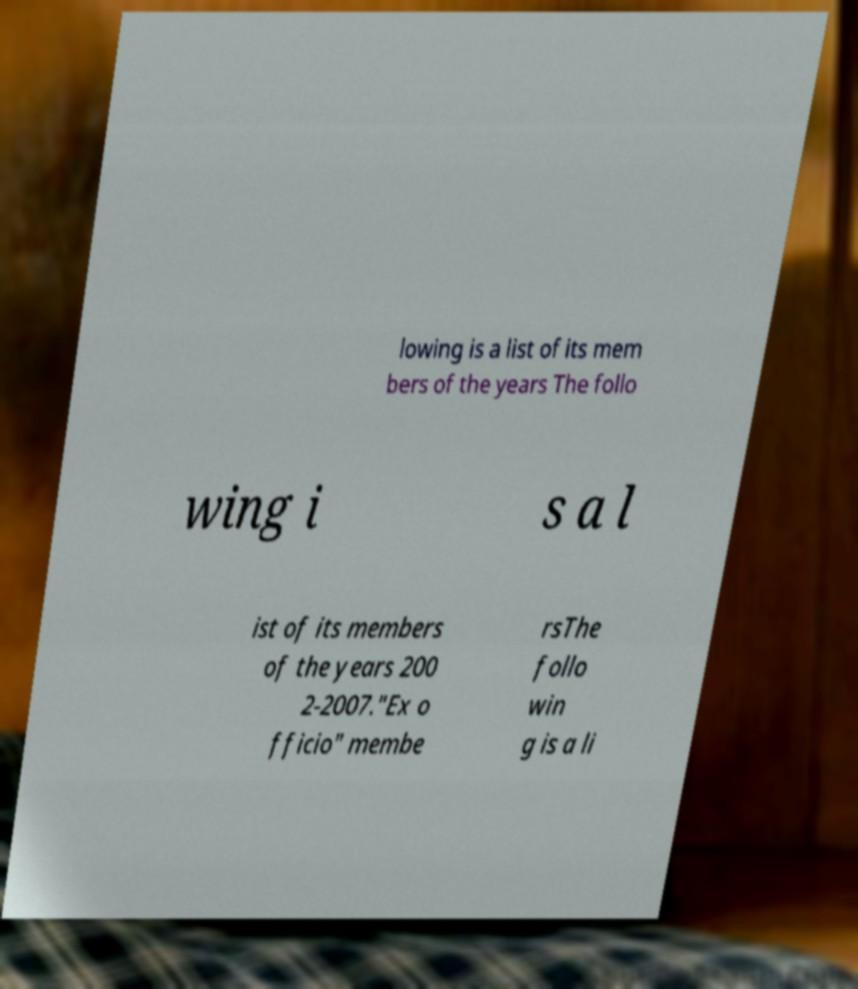Could you assist in decoding the text presented in this image and type it out clearly? lowing is a list of its mem bers of the years The follo wing i s a l ist of its members of the years 200 2-2007."Ex o fficio" membe rsThe follo win g is a li 